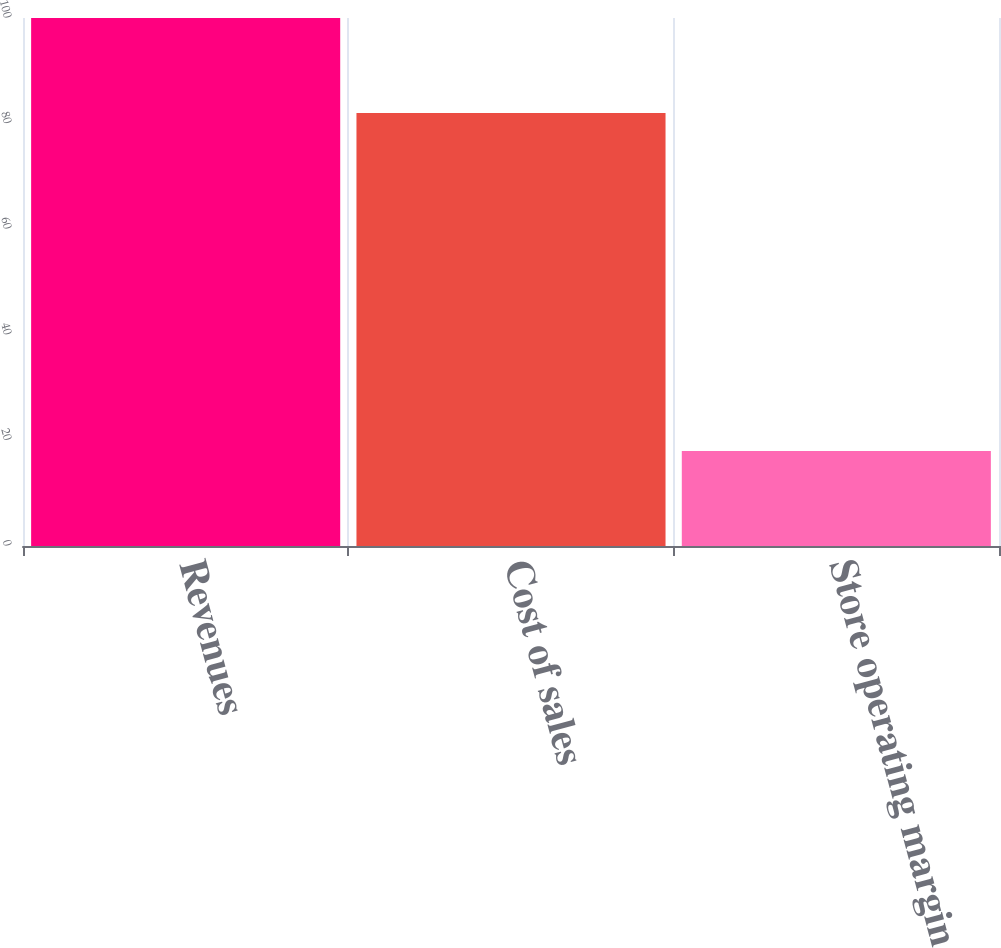Convert chart. <chart><loc_0><loc_0><loc_500><loc_500><bar_chart><fcel>Revenues<fcel>Cost of sales<fcel>Store operating margin<nl><fcel>100<fcel>82<fcel>18<nl></chart> 